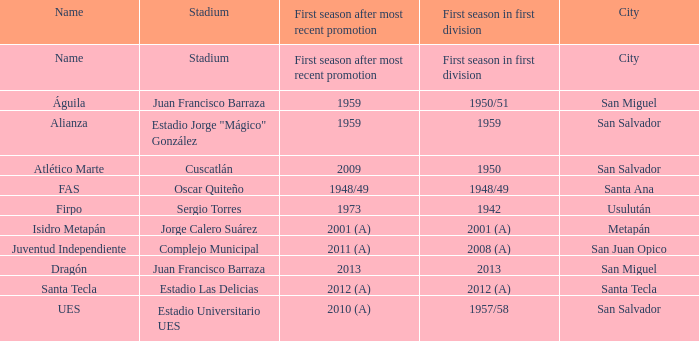Which city is Alianza? San Salvador. 